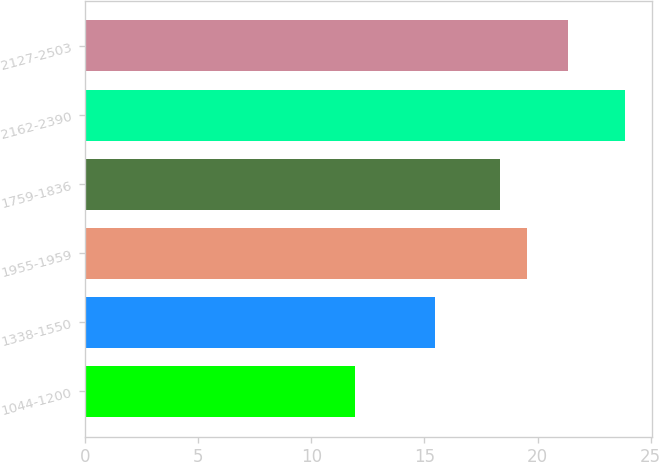Convert chart to OTSL. <chart><loc_0><loc_0><loc_500><loc_500><bar_chart><fcel>1044-1200<fcel>1338-1550<fcel>1955-1959<fcel>1759-1836<fcel>2162-2390<fcel>2127-2503<nl><fcel>11.92<fcel>15.46<fcel>19.55<fcel>18.34<fcel>23.88<fcel>21.34<nl></chart> 